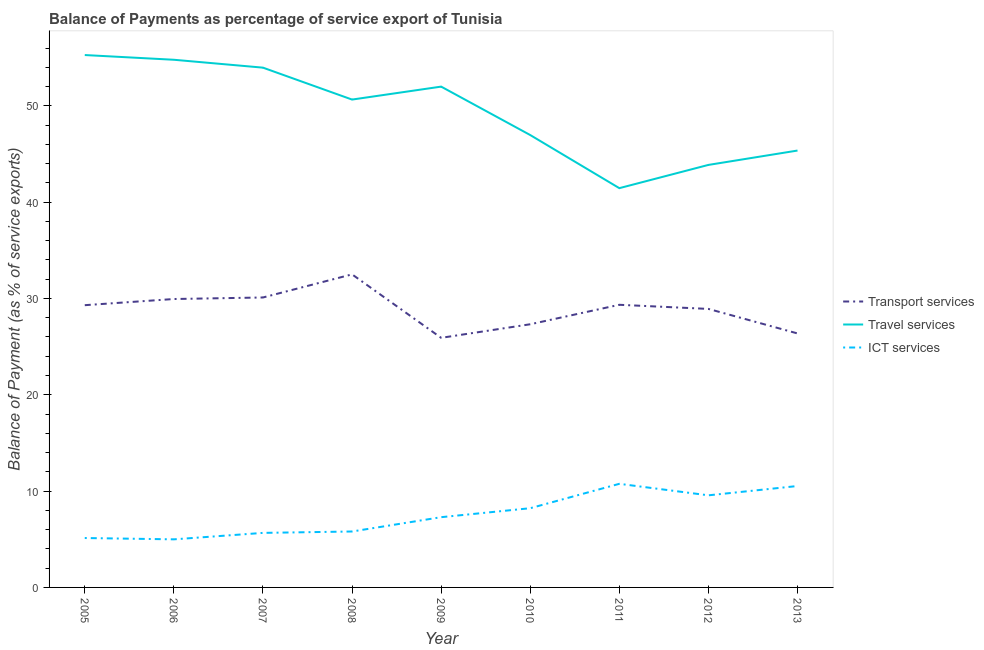How many different coloured lines are there?
Offer a very short reply. 3. Is the number of lines equal to the number of legend labels?
Make the answer very short. Yes. What is the balance of payment of travel services in 2008?
Your answer should be very brief. 50.65. Across all years, what is the maximum balance of payment of travel services?
Keep it short and to the point. 55.27. Across all years, what is the minimum balance of payment of travel services?
Your response must be concise. 41.45. In which year was the balance of payment of ict services maximum?
Your answer should be very brief. 2011. In which year was the balance of payment of travel services minimum?
Your response must be concise. 2011. What is the total balance of payment of ict services in the graph?
Offer a very short reply. 67.95. What is the difference between the balance of payment of transport services in 2011 and that in 2013?
Your answer should be compact. 2.97. What is the difference between the balance of payment of ict services in 2013 and the balance of payment of travel services in 2012?
Offer a very short reply. -33.33. What is the average balance of payment of travel services per year?
Keep it short and to the point. 49.36. In the year 2011, what is the difference between the balance of payment of ict services and balance of payment of transport services?
Offer a very short reply. -18.59. What is the ratio of the balance of payment of travel services in 2006 to that in 2009?
Keep it short and to the point. 1.05. Is the balance of payment of transport services in 2009 less than that in 2010?
Your response must be concise. Yes. Is the difference between the balance of payment of travel services in 2010 and 2011 greater than the difference between the balance of payment of transport services in 2010 and 2011?
Ensure brevity in your answer.  Yes. What is the difference between the highest and the second highest balance of payment of ict services?
Offer a very short reply. 0.23. What is the difference between the highest and the lowest balance of payment of travel services?
Provide a short and direct response. 13.82. Is the sum of the balance of payment of transport services in 2006 and 2007 greater than the maximum balance of payment of travel services across all years?
Offer a very short reply. Yes. Is it the case that in every year, the sum of the balance of payment of transport services and balance of payment of travel services is greater than the balance of payment of ict services?
Your answer should be very brief. Yes. Is the balance of payment of travel services strictly greater than the balance of payment of ict services over the years?
Your response must be concise. Yes. Is the balance of payment of transport services strictly less than the balance of payment of travel services over the years?
Provide a short and direct response. Yes. How many years are there in the graph?
Keep it short and to the point. 9. What is the difference between two consecutive major ticks on the Y-axis?
Your answer should be very brief. 10. Are the values on the major ticks of Y-axis written in scientific E-notation?
Offer a terse response. No. Does the graph contain any zero values?
Provide a short and direct response. No. Does the graph contain grids?
Offer a terse response. No. Where does the legend appear in the graph?
Keep it short and to the point. Center right. How many legend labels are there?
Keep it short and to the point. 3. How are the legend labels stacked?
Your answer should be compact. Vertical. What is the title of the graph?
Make the answer very short. Balance of Payments as percentage of service export of Tunisia. What is the label or title of the Y-axis?
Provide a succinct answer. Balance of Payment (as % of service exports). What is the Balance of Payment (as % of service exports) of Transport services in 2005?
Offer a terse response. 29.3. What is the Balance of Payment (as % of service exports) in Travel services in 2005?
Give a very brief answer. 55.27. What is the Balance of Payment (as % of service exports) in ICT services in 2005?
Make the answer very short. 5.13. What is the Balance of Payment (as % of service exports) in Transport services in 2006?
Your answer should be compact. 29.94. What is the Balance of Payment (as % of service exports) of Travel services in 2006?
Your answer should be compact. 54.78. What is the Balance of Payment (as % of service exports) in ICT services in 2006?
Provide a short and direct response. 4.99. What is the Balance of Payment (as % of service exports) in Transport services in 2007?
Keep it short and to the point. 30.1. What is the Balance of Payment (as % of service exports) of Travel services in 2007?
Provide a succinct answer. 53.96. What is the Balance of Payment (as % of service exports) in ICT services in 2007?
Your answer should be very brief. 5.66. What is the Balance of Payment (as % of service exports) in Transport services in 2008?
Make the answer very short. 32.5. What is the Balance of Payment (as % of service exports) of Travel services in 2008?
Make the answer very short. 50.65. What is the Balance of Payment (as % of service exports) of ICT services in 2008?
Your answer should be compact. 5.81. What is the Balance of Payment (as % of service exports) of Transport services in 2009?
Make the answer very short. 25.91. What is the Balance of Payment (as % of service exports) in Travel services in 2009?
Offer a terse response. 51.99. What is the Balance of Payment (as % of service exports) of ICT services in 2009?
Give a very brief answer. 7.29. What is the Balance of Payment (as % of service exports) of Transport services in 2010?
Your answer should be very brief. 27.32. What is the Balance of Payment (as % of service exports) of Travel services in 2010?
Provide a short and direct response. 46.96. What is the Balance of Payment (as % of service exports) in ICT services in 2010?
Offer a terse response. 8.22. What is the Balance of Payment (as % of service exports) in Transport services in 2011?
Make the answer very short. 29.34. What is the Balance of Payment (as % of service exports) of Travel services in 2011?
Your answer should be compact. 41.45. What is the Balance of Payment (as % of service exports) in ICT services in 2011?
Make the answer very short. 10.76. What is the Balance of Payment (as % of service exports) in Transport services in 2012?
Keep it short and to the point. 28.91. What is the Balance of Payment (as % of service exports) of Travel services in 2012?
Provide a succinct answer. 43.86. What is the Balance of Payment (as % of service exports) of ICT services in 2012?
Give a very brief answer. 9.56. What is the Balance of Payment (as % of service exports) in Transport services in 2013?
Give a very brief answer. 26.37. What is the Balance of Payment (as % of service exports) of Travel services in 2013?
Offer a terse response. 45.35. What is the Balance of Payment (as % of service exports) in ICT services in 2013?
Ensure brevity in your answer.  10.53. Across all years, what is the maximum Balance of Payment (as % of service exports) of Transport services?
Make the answer very short. 32.5. Across all years, what is the maximum Balance of Payment (as % of service exports) in Travel services?
Offer a terse response. 55.27. Across all years, what is the maximum Balance of Payment (as % of service exports) in ICT services?
Your answer should be very brief. 10.76. Across all years, what is the minimum Balance of Payment (as % of service exports) in Transport services?
Offer a terse response. 25.91. Across all years, what is the minimum Balance of Payment (as % of service exports) of Travel services?
Your response must be concise. 41.45. Across all years, what is the minimum Balance of Payment (as % of service exports) of ICT services?
Your response must be concise. 4.99. What is the total Balance of Payment (as % of service exports) of Transport services in the graph?
Your answer should be very brief. 259.7. What is the total Balance of Payment (as % of service exports) of Travel services in the graph?
Your answer should be very brief. 444.28. What is the total Balance of Payment (as % of service exports) in ICT services in the graph?
Offer a very short reply. 67.95. What is the difference between the Balance of Payment (as % of service exports) of Transport services in 2005 and that in 2006?
Provide a short and direct response. -0.64. What is the difference between the Balance of Payment (as % of service exports) in Travel services in 2005 and that in 2006?
Keep it short and to the point. 0.49. What is the difference between the Balance of Payment (as % of service exports) in ICT services in 2005 and that in 2006?
Your answer should be compact. 0.14. What is the difference between the Balance of Payment (as % of service exports) in Transport services in 2005 and that in 2007?
Your answer should be very brief. -0.8. What is the difference between the Balance of Payment (as % of service exports) in Travel services in 2005 and that in 2007?
Your response must be concise. 1.31. What is the difference between the Balance of Payment (as % of service exports) of ICT services in 2005 and that in 2007?
Ensure brevity in your answer.  -0.53. What is the difference between the Balance of Payment (as % of service exports) of Transport services in 2005 and that in 2008?
Ensure brevity in your answer.  -3.2. What is the difference between the Balance of Payment (as % of service exports) in Travel services in 2005 and that in 2008?
Your response must be concise. 4.62. What is the difference between the Balance of Payment (as % of service exports) in ICT services in 2005 and that in 2008?
Keep it short and to the point. -0.68. What is the difference between the Balance of Payment (as % of service exports) in Transport services in 2005 and that in 2009?
Your response must be concise. 3.39. What is the difference between the Balance of Payment (as % of service exports) of Travel services in 2005 and that in 2009?
Offer a terse response. 3.28. What is the difference between the Balance of Payment (as % of service exports) of ICT services in 2005 and that in 2009?
Provide a short and direct response. -2.16. What is the difference between the Balance of Payment (as % of service exports) of Transport services in 2005 and that in 2010?
Keep it short and to the point. 1.98. What is the difference between the Balance of Payment (as % of service exports) in Travel services in 2005 and that in 2010?
Your answer should be compact. 8.31. What is the difference between the Balance of Payment (as % of service exports) in ICT services in 2005 and that in 2010?
Provide a short and direct response. -3.1. What is the difference between the Balance of Payment (as % of service exports) of Transport services in 2005 and that in 2011?
Give a very brief answer. -0.04. What is the difference between the Balance of Payment (as % of service exports) in Travel services in 2005 and that in 2011?
Your answer should be compact. 13.82. What is the difference between the Balance of Payment (as % of service exports) of ICT services in 2005 and that in 2011?
Keep it short and to the point. -5.63. What is the difference between the Balance of Payment (as % of service exports) in Transport services in 2005 and that in 2012?
Keep it short and to the point. 0.39. What is the difference between the Balance of Payment (as % of service exports) in Travel services in 2005 and that in 2012?
Provide a short and direct response. 11.41. What is the difference between the Balance of Payment (as % of service exports) of ICT services in 2005 and that in 2012?
Make the answer very short. -4.43. What is the difference between the Balance of Payment (as % of service exports) in Transport services in 2005 and that in 2013?
Offer a terse response. 2.93. What is the difference between the Balance of Payment (as % of service exports) of Travel services in 2005 and that in 2013?
Give a very brief answer. 9.92. What is the difference between the Balance of Payment (as % of service exports) of ICT services in 2005 and that in 2013?
Your answer should be compact. -5.4. What is the difference between the Balance of Payment (as % of service exports) of Transport services in 2006 and that in 2007?
Give a very brief answer. -0.16. What is the difference between the Balance of Payment (as % of service exports) of Travel services in 2006 and that in 2007?
Your answer should be compact. 0.82. What is the difference between the Balance of Payment (as % of service exports) in ICT services in 2006 and that in 2007?
Provide a succinct answer. -0.67. What is the difference between the Balance of Payment (as % of service exports) in Transport services in 2006 and that in 2008?
Keep it short and to the point. -2.56. What is the difference between the Balance of Payment (as % of service exports) in Travel services in 2006 and that in 2008?
Give a very brief answer. 4.13. What is the difference between the Balance of Payment (as % of service exports) of ICT services in 2006 and that in 2008?
Your answer should be very brief. -0.82. What is the difference between the Balance of Payment (as % of service exports) of Transport services in 2006 and that in 2009?
Your response must be concise. 4.03. What is the difference between the Balance of Payment (as % of service exports) of Travel services in 2006 and that in 2009?
Keep it short and to the point. 2.79. What is the difference between the Balance of Payment (as % of service exports) in ICT services in 2006 and that in 2009?
Ensure brevity in your answer.  -2.3. What is the difference between the Balance of Payment (as % of service exports) in Transport services in 2006 and that in 2010?
Make the answer very short. 2.62. What is the difference between the Balance of Payment (as % of service exports) of Travel services in 2006 and that in 2010?
Provide a short and direct response. 7.82. What is the difference between the Balance of Payment (as % of service exports) in ICT services in 2006 and that in 2010?
Give a very brief answer. -3.23. What is the difference between the Balance of Payment (as % of service exports) in Transport services in 2006 and that in 2011?
Offer a very short reply. 0.6. What is the difference between the Balance of Payment (as % of service exports) in Travel services in 2006 and that in 2011?
Provide a short and direct response. 13.33. What is the difference between the Balance of Payment (as % of service exports) of ICT services in 2006 and that in 2011?
Offer a very short reply. -5.76. What is the difference between the Balance of Payment (as % of service exports) of Transport services in 2006 and that in 2012?
Provide a succinct answer. 1.03. What is the difference between the Balance of Payment (as % of service exports) in Travel services in 2006 and that in 2012?
Provide a succinct answer. 10.92. What is the difference between the Balance of Payment (as % of service exports) of ICT services in 2006 and that in 2012?
Offer a very short reply. -4.57. What is the difference between the Balance of Payment (as % of service exports) in Transport services in 2006 and that in 2013?
Your answer should be compact. 3.57. What is the difference between the Balance of Payment (as % of service exports) of Travel services in 2006 and that in 2013?
Provide a short and direct response. 9.43. What is the difference between the Balance of Payment (as % of service exports) of ICT services in 2006 and that in 2013?
Offer a terse response. -5.54. What is the difference between the Balance of Payment (as % of service exports) in Transport services in 2007 and that in 2008?
Give a very brief answer. -2.4. What is the difference between the Balance of Payment (as % of service exports) of Travel services in 2007 and that in 2008?
Make the answer very short. 3.31. What is the difference between the Balance of Payment (as % of service exports) of ICT services in 2007 and that in 2008?
Your answer should be very brief. -0.14. What is the difference between the Balance of Payment (as % of service exports) of Transport services in 2007 and that in 2009?
Your answer should be very brief. 4.19. What is the difference between the Balance of Payment (as % of service exports) in Travel services in 2007 and that in 2009?
Your answer should be compact. 1.97. What is the difference between the Balance of Payment (as % of service exports) in ICT services in 2007 and that in 2009?
Ensure brevity in your answer.  -1.63. What is the difference between the Balance of Payment (as % of service exports) in Transport services in 2007 and that in 2010?
Provide a short and direct response. 2.78. What is the difference between the Balance of Payment (as % of service exports) of Travel services in 2007 and that in 2010?
Your response must be concise. 7. What is the difference between the Balance of Payment (as % of service exports) of ICT services in 2007 and that in 2010?
Offer a terse response. -2.56. What is the difference between the Balance of Payment (as % of service exports) of Transport services in 2007 and that in 2011?
Keep it short and to the point. 0.76. What is the difference between the Balance of Payment (as % of service exports) in Travel services in 2007 and that in 2011?
Offer a very short reply. 12.51. What is the difference between the Balance of Payment (as % of service exports) of ICT services in 2007 and that in 2011?
Your response must be concise. -5.09. What is the difference between the Balance of Payment (as % of service exports) in Transport services in 2007 and that in 2012?
Provide a succinct answer. 1.19. What is the difference between the Balance of Payment (as % of service exports) of Travel services in 2007 and that in 2012?
Your response must be concise. 10.1. What is the difference between the Balance of Payment (as % of service exports) in ICT services in 2007 and that in 2012?
Give a very brief answer. -3.9. What is the difference between the Balance of Payment (as % of service exports) of Transport services in 2007 and that in 2013?
Your answer should be very brief. 3.73. What is the difference between the Balance of Payment (as % of service exports) of Travel services in 2007 and that in 2013?
Give a very brief answer. 8.61. What is the difference between the Balance of Payment (as % of service exports) of ICT services in 2007 and that in 2013?
Ensure brevity in your answer.  -4.87. What is the difference between the Balance of Payment (as % of service exports) in Transport services in 2008 and that in 2009?
Give a very brief answer. 6.59. What is the difference between the Balance of Payment (as % of service exports) in Travel services in 2008 and that in 2009?
Provide a short and direct response. -1.34. What is the difference between the Balance of Payment (as % of service exports) of ICT services in 2008 and that in 2009?
Provide a succinct answer. -1.49. What is the difference between the Balance of Payment (as % of service exports) in Transport services in 2008 and that in 2010?
Your response must be concise. 5.18. What is the difference between the Balance of Payment (as % of service exports) of Travel services in 2008 and that in 2010?
Ensure brevity in your answer.  3.68. What is the difference between the Balance of Payment (as % of service exports) of ICT services in 2008 and that in 2010?
Offer a terse response. -2.42. What is the difference between the Balance of Payment (as % of service exports) in Transport services in 2008 and that in 2011?
Ensure brevity in your answer.  3.16. What is the difference between the Balance of Payment (as % of service exports) in Travel services in 2008 and that in 2011?
Make the answer very short. 9.2. What is the difference between the Balance of Payment (as % of service exports) in ICT services in 2008 and that in 2011?
Your answer should be compact. -4.95. What is the difference between the Balance of Payment (as % of service exports) in Transport services in 2008 and that in 2012?
Provide a short and direct response. 3.59. What is the difference between the Balance of Payment (as % of service exports) of Travel services in 2008 and that in 2012?
Provide a succinct answer. 6.78. What is the difference between the Balance of Payment (as % of service exports) of ICT services in 2008 and that in 2012?
Keep it short and to the point. -3.76. What is the difference between the Balance of Payment (as % of service exports) in Transport services in 2008 and that in 2013?
Provide a short and direct response. 6.13. What is the difference between the Balance of Payment (as % of service exports) in Travel services in 2008 and that in 2013?
Your answer should be compact. 5.29. What is the difference between the Balance of Payment (as % of service exports) of ICT services in 2008 and that in 2013?
Give a very brief answer. -4.72. What is the difference between the Balance of Payment (as % of service exports) in Transport services in 2009 and that in 2010?
Give a very brief answer. -1.41. What is the difference between the Balance of Payment (as % of service exports) of Travel services in 2009 and that in 2010?
Ensure brevity in your answer.  5.03. What is the difference between the Balance of Payment (as % of service exports) of ICT services in 2009 and that in 2010?
Your answer should be compact. -0.93. What is the difference between the Balance of Payment (as % of service exports) in Transport services in 2009 and that in 2011?
Your answer should be very brief. -3.43. What is the difference between the Balance of Payment (as % of service exports) in Travel services in 2009 and that in 2011?
Provide a succinct answer. 10.54. What is the difference between the Balance of Payment (as % of service exports) in ICT services in 2009 and that in 2011?
Give a very brief answer. -3.46. What is the difference between the Balance of Payment (as % of service exports) in Transport services in 2009 and that in 2012?
Your answer should be very brief. -3. What is the difference between the Balance of Payment (as % of service exports) in Travel services in 2009 and that in 2012?
Give a very brief answer. 8.13. What is the difference between the Balance of Payment (as % of service exports) of ICT services in 2009 and that in 2012?
Offer a terse response. -2.27. What is the difference between the Balance of Payment (as % of service exports) in Transport services in 2009 and that in 2013?
Give a very brief answer. -0.46. What is the difference between the Balance of Payment (as % of service exports) of Travel services in 2009 and that in 2013?
Give a very brief answer. 6.64. What is the difference between the Balance of Payment (as % of service exports) in ICT services in 2009 and that in 2013?
Your answer should be compact. -3.24. What is the difference between the Balance of Payment (as % of service exports) of Transport services in 2010 and that in 2011?
Provide a short and direct response. -2.02. What is the difference between the Balance of Payment (as % of service exports) of Travel services in 2010 and that in 2011?
Ensure brevity in your answer.  5.51. What is the difference between the Balance of Payment (as % of service exports) in ICT services in 2010 and that in 2011?
Ensure brevity in your answer.  -2.53. What is the difference between the Balance of Payment (as % of service exports) in Transport services in 2010 and that in 2012?
Provide a short and direct response. -1.59. What is the difference between the Balance of Payment (as % of service exports) of Travel services in 2010 and that in 2012?
Keep it short and to the point. 3.1. What is the difference between the Balance of Payment (as % of service exports) in ICT services in 2010 and that in 2012?
Your answer should be compact. -1.34. What is the difference between the Balance of Payment (as % of service exports) of Transport services in 2010 and that in 2013?
Ensure brevity in your answer.  0.95. What is the difference between the Balance of Payment (as % of service exports) in Travel services in 2010 and that in 2013?
Your answer should be compact. 1.61. What is the difference between the Balance of Payment (as % of service exports) of ICT services in 2010 and that in 2013?
Keep it short and to the point. -2.3. What is the difference between the Balance of Payment (as % of service exports) of Transport services in 2011 and that in 2012?
Keep it short and to the point. 0.43. What is the difference between the Balance of Payment (as % of service exports) of Travel services in 2011 and that in 2012?
Ensure brevity in your answer.  -2.41. What is the difference between the Balance of Payment (as % of service exports) of ICT services in 2011 and that in 2012?
Provide a short and direct response. 1.19. What is the difference between the Balance of Payment (as % of service exports) in Transport services in 2011 and that in 2013?
Give a very brief answer. 2.97. What is the difference between the Balance of Payment (as % of service exports) in Travel services in 2011 and that in 2013?
Keep it short and to the point. -3.9. What is the difference between the Balance of Payment (as % of service exports) in ICT services in 2011 and that in 2013?
Provide a succinct answer. 0.23. What is the difference between the Balance of Payment (as % of service exports) in Transport services in 2012 and that in 2013?
Provide a short and direct response. 2.55. What is the difference between the Balance of Payment (as % of service exports) in Travel services in 2012 and that in 2013?
Make the answer very short. -1.49. What is the difference between the Balance of Payment (as % of service exports) in ICT services in 2012 and that in 2013?
Give a very brief answer. -0.97. What is the difference between the Balance of Payment (as % of service exports) in Transport services in 2005 and the Balance of Payment (as % of service exports) in Travel services in 2006?
Your response must be concise. -25.48. What is the difference between the Balance of Payment (as % of service exports) in Transport services in 2005 and the Balance of Payment (as % of service exports) in ICT services in 2006?
Your answer should be compact. 24.31. What is the difference between the Balance of Payment (as % of service exports) in Travel services in 2005 and the Balance of Payment (as % of service exports) in ICT services in 2006?
Keep it short and to the point. 50.28. What is the difference between the Balance of Payment (as % of service exports) of Transport services in 2005 and the Balance of Payment (as % of service exports) of Travel services in 2007?
Provide a short and direct response. -24.66. What is the difference between the Balance of Payment (as % of service exports) of Transport services in 2005 and the Balance of Payment (as % of service exports) of ICT services in 2007?
Your answer should be compact. 23.64. What is the difference between the Balance of Payment (as % of service exports) in Travel services in 2005 and the Balance of Payment (as % of service exports) in ICT services in 2007?
Offer a very short reply. 49.61. What is the difference between the Balance of Payment (as % of service exports) of Transport services in 2005 and the Balance of Payment (as % of service exports) of Travel services in 2008?
Keep it short and to the point. -21.35. What is the difference between the Balance of Payment (as % of service exports) in Transport services in 2005 and the Balance of Payment (as % of service exports) in ICT services in 2008?
Your response must be concise. 23.49. What is the difference between the Balance of Payment (as % of service exports) of Travel services in 2005 and the Balance of Payment (as % of service exports) of ICT services in 2008?
Provide a short and direct response. 49.46. What is the difference between the Balance of Payment (as % of service exports) in Transport services in 2005 and the Balance of Payment (as % of service exports) in Travel services in 2009?
Keep it short and to the point. -22.69. What is the difference between the Balance of Payment (as % of service exports) in Transport services in 2005 and the Balance of Payment (as % of service exports) in ICT services in 2009?
Provide a short and direct response. 22.01. What is the difference between the Balance of Payment (as % of service exports) in Travel services in 2005 and the Balance of Payment (as % of service exports) in ICT services in 2009?
Offer a terse response. 47.98. What is the difference between the Balance of Payment (as % of service exports) in Transport services in 2005 and the Balance of Payment (as % of service exports) in Travel services in 2010?
Your answer should be very brief. -17.66. What is the difference between the Balance of Payment (as % of service exports) in Transport services in 2005 and the Balance of Payment (as % of service exports) in ICT services in 2010?
Make the answer very short. 21.08. What is the difference between the Balance of Payment (as % of service exports) of Travel services in 2005 and the Balance of Payment (as % of service exports) of ICT services in 2010?
Make the answer very short. 47.05. What is the difference between the Balance of Payment (as % of service exports) of Transport services in 2005 and the Balance of Payment (as % of service exports) of Travel services in 2011?
Your answer should be compact. -12.15. What is the difference between the Balance of Payment (as % of service exports) in Transport services in 2005 and the Balance of Payment (as % of service exports) in ICT services in 2011?
Make the answer very short. 18.55. What is the difference between the Balance of Payment (as % of service exports) of Travel services in 2005 and the Balance of Payment (as % of service exports) of ICT services in 2011?
Your response must be concise. 44.51. What is the difference between the Balance of Payment (as % of service exports) of Transport services in 2005 and the Balance of Payment (as % of service exports) of Travel services in 2012?
Offer a terse response. -14.56. What is the difference between the Balance of Payment (as % of service exports) in Transport services in 2005 and the Balance of Payment (as % of service exports) in ICT services in 2012?
Provide a short and direct response. 19.74. What is the difference between the Balance of Payment (as % of service exports) in Travel services in 2005 and the Balance of Payment (as % of service exports) in ICT services in 2012?
Provide a short and direct response. 45.71. What is the difference between the Balance of Payment (as % of service exports) of Transport services in 2005 and the Balance of Payment (as % of service exports) of Travel services in 2013?
Provide a short and direct response. -16.05. What is the difference between the Balance of Payment (as % of service exports) in Transport services in 2005 and the Balance of Payment (as % of service exports) in ICT services in 2013?
Your answer should be compact. 18.77. What is the difference between the Balance of Payment (as % of service exports) in Travel services in 2005 and the Balance of Payment (as % of service exports) in ICT services in 2013?
Offer a terse response. 44.74. What is the difference between the Balance of Payment (as % of service exports) in Transport services in 2006 and the Balance of Payment (as % of service exports) in Travel services in 2007?
Provide a short and direct response. -24.02. What is the difference between the Balance of Payment (as % of service exports) in Transport services in 2006 and the Balance of Payment (as % of service exports) in ICT services in 2007?
Your answer should be very brief. 24.28. What is the difference between the Balance of Payment (as % of service exports) of Travel services in 2006 and the Balance of Payment (as % of service exports) of ICT services in 2007?
Provide a succinct answer. 49.12. What is the difference between the Balance of Payment (as % of service exports) in Transport services in 2006 and the Balance of Payment (as % of service exports) in Travel services in 2008?
Give a very brief answer. -20.71. What is the difference between the Balance of Payment (as % of service exports) in Transport services in 2006 and the Balance of Payment (as % of service exports) in ICT services in 2008?
Your response must be concise. 24.14. What is the difference between the Balance of Payment (as % of service exports) of Travel services in 2006 and the Balance of Payment (as % of service exports) of ICT services in 2008?
Your answer should be very brief. 48.97. What is the difference between the Balance of Payment (as % of service exports) of Transport services in 2006 and the Balance of Payment (as % of service exports) of Travel services in 2009?
Ensure brevity in your answer.  -22.05. What is the difference between the Balance of Payment (as % of service exports) in Transport services in 2006 and the Balance of Payment (as % of service exports) in ICT services in 2009?
Give a very brief answer. 22.65. What is the difference between the Balance of Payment (as % of service exports) in Travel services in 2006 and the Balance of Payment (as % of service exports) in ICT services in 2009?
Offer a very short reply. 47.49. What is the difference between the Balance of Payment (as % of service exports) in Transport services in 2006 and the Balance of Payment (as % of service exports) in Travel services in 2010?
Provide a short and direct response. -17.02. What is the difference between the Balance of Payment (as % of service exports) of Transport services in 2006 and the Balance of Payment (as % of service exports) of ICT services in 2010?
Ensure brevity in your answer.  21.72. What is the difference between the Balance of Payment (as % of service exports) in Travel services in 2006 and the Balance of Payment (as % of service exports) in ICT services in 2010?
Keep it short and to the point. 46.55. What is the difference between the Balance of Payment (as % of service exports) in Transport services in 2006 and the Balance of Payment (as % of service exports) in Travel services in 2011?
Your answer should be very brief. -11.51. What is the difference between the Balance of Payment (as % of service exports) in Transport services in 2006 and the Balance of Payment (as % of service exports) in ICT services in 2011?
Offer a very short reply. 19.19. What is the difference between the Balance of Payment (as % of service exports) in Travel services in 2006 and the Balance of Payment (as % of service exports) in ICT services in 2011?
Provide a short and direct response. 44.02. What is the difference between the Balance of Payment (as % of service exports) in Transport services in 2006 and the Balance of Payment (as % of service exports) in Travel services in 2012?
Offer a very short reply. -13.92. What is the difference between the Balance of Payment (as % of service exports) in Transport services in 2006 and the Balance of Payment (as % of service exports) in ICT services in 2012?
Offer a terse response. 20.38. What is the difference between the Balance of Payment (as % of service exports) of Travel services in 2006 and the Balance of Payment (as % of service exports) of ICT services in 2012?
Ensure brevity in your answer.  45.22. What is the difference between the Balance of Payment (as % of service exports) of Transport services in 2006 and the Balance of Payment (as % of service exports) of Travel services in 2013?
Offer a terse response. -15.41. What is the difference between the Balance of Payment (as % of service exports) in Transport services in 2006 and the Balance of Payment (as % of service exports) in ICT services in 2013?
Provide a short and direct response. 19.41. What is the difference between the Balance of Payment (as % of service exports) of Travel services in 2006 and the Balance of Payment (as % of service exports) of ICT services in 2013?
Your answer should be very brief. 44.25. What is the difference between the Balance of Payment (as % of service exports) of Transport services in 2007 and the Balance of Payment (as % of service exports) of Travel services in 2008?
Offer a terse response. -20.55. What is the difference between the Balance of Payment (as % of service exports) of Transport services in 2007 and the Balance of Payment (as % of service exports) of ICT services in 2008?
Your answer should be compact. 24.29. What is the difference between the Balance of Payment (as % of service exports) of Travel services in 2007 and the Balance of Payment (as % of service exports) of ICT services in 2008?
Your response must be concise. 48.15. What is the difference between the Balance of Payment (as % of service exports) in Transport services in 2007 and the Balance of Payment (as % of service exports) in Travel services in 2009?
Your response must be concise. -21.89. What is the difference between the Balance of Payment (as % of service exports) in Transport services in 2007 and the Balance of Payment (as % of service exports) in ICT services in 2009?
Make the answer very short. 22.81. What is the difference between the Balance of Payment (as % of service exports) of Travel services in 2007 and the Balance of Payment (as % of service exports) of ICT services in 2009?
Your response must be concise. 46.67. What is the difference between the Balance of Payment (as % of service exports) of Transport services in 2007 and the Balance of Payment (as % of service exports) of Travel services in 2010?
Make the answer very short. -16.86. What is the difference between the Balance of Payment (as % of service exports) in Transport services in 2007 and the Balance of Payment (as % of service exports) in ICT services in 2010?
Make the answer very short. 21.88. What is the difference between the Balance of Payment (as % of service exports) of Travel services in 2007 and the Balance of Payment (as % of service exports) of ICT services in 2010?
Your answer should be compact. 45.74. What is the difference between the Balance of Payment (as % of service exports) of Transport services in 2007 and the Balance of Payment (as % of service exports) of Travel services in 2011?
Your answer should be compact. -11.35. What is the difference between the Balance of Payment (as % of service exports) in Transport services in 2007 and the Balance of Payment (as % of service exports) in ICT services in 2011?
Make the answer very short. 19.34. What is the difference between the Balance of Payment (as % of service exports) in Travel services in 2007 and the Balance of Payment (as % of service exports) in ICT services in 2011?
Provide a succinct answer. 43.21. What is the difference between the Balance of Payment (as % of service exports) of Transport services in 2007 and the Balance of Payment (as % of service exports) of Travel services in 2012?
Provide a succinct answer. -13.76. What is the difference between the Balance of Payment (as % of service exports) of Transport services in 2007 and the Balance of Payment (as % of service exports) of ICT services in 2012?
Your response must be concise. 20.54. What is the difference between the Balance of Payment (as % of service exports) of Travel services in 2007 and the Balance of Payment (as % of service exports) of ICT services in 2012?
Provide a short and direct response. 44.4. What is the difference between the Balance of Payment (as % of service exports) of Transport services in 2007 and the Balance of Payment (as % of service exports) of Travel services in 2013?
Your answer should be compact. -15.25. What is the difference between the Balance of Payment (as % of service exports) of Transport services in 2007 and the Balance of Payment (as % of service exports) of ICT services in 2013?
Keep it short and to the point. 19.57. What is the difference between the Balance of Payment (as % of service exports) in Travel services in 2007 and the Balance of Payment (as % of service exports) in ICT services in 2013?
Offer a very short reply. 43.43. What is the difference between the Balance of Payment (as % of service exports) in Transport services in 2008 and the Balance of Payment (as % of service exports) in Travel services in 2009?
Make the answer very short. -19.49. What is the difference between the Balance of Payment (as % of service exports) in Transport services in 2008 and the Balance of Payment (as % of service exports) in ICT services in 2009?
Offer a terse response. 25.21. What is the difference between the Balance of Payment (as % of service exports) of Travel services in 2008 and the Balance of Payment (as % of service exports) of ICT services in 2009?
Ensure brevity in your answer.  43.35. What is the difference between the Balance of Payment (as % of service exports) of Transport services in 2008 and the Balance of Payment (as % of service exports) of Travel services in 2010?
Keep it short and to the point. -14.46. What is the difference between the Balance of Payment (as % of service exports) of Transport services in 2008 and the Balance of Payment (as % of service exports) of ICT services in 2010?
Your answer should be compact. 24.28. What is the difference between the Balance of Payment (as % of service exports) in Travel services in 2008 and the Balance of Payment (as % of service exports) in ICT services in 2010?
Ensure brevity in your answer.  42.42. What is the difference between the Balance of Payment (as % of service exports) of Transport services in 2008 and the Balance of Payment (as % of service exports) of Travel services in 2011?
Offer a terse response. -8.95. What is the difference between the Balance of Payment (as % of service exports) in Transport services in 2008 and the Balance of Payment (as % of service exports) in ICT services in 2011?
Provide a short and direct response. 21.74. What is the difference between the Balance of Payment (as % of service exports) in Travel services in 2008 and the Balance of Payment (as % of service exports) in ICT services in 2011?
Provide a short and direct response. 39.89. What is the difference between the Balance of Payment (as % of service exports) in Transport services in 2008 and the Balance of Payment (as % of service exports) in Travel services in 2012?
Make the answer very short. -11.36. What is the difference between the Balance of Payment (as % of service exports) of Transport services in 2008 and the Balance of Payment (as % of service exports) of ICT services in 2012?
Your answer should be very brief. 22.94. What is the difference between the Balance of Payment (as % of service exports) of Travel services in 2008 and the Balance of Payment (as % of service exports) of ICT services in 2012?
Offer a terse response. 41.09. What is the difference between the Balance of Payment (as % of service exports) of Transport services in 2008 and the Balance of Payment (as % of service exports) of Travel services in 2013?
Keep it short and to the point. -12.85. What is the difference between the Balance of Payment (as % of service exports) in Transport services in 2008 and the Balance of Payment (as % of service exports) in ICT services in 2013?
Provide a succinct answer. 21.97. What is the difference between the Balance of Payment (as % of service exports) in Travel services in 2008 and the Balance of Payment (as % of service exports) in ICT services in 2013?
Keep it short and to the point. 40.12. What is the difference between the Balance of Payment (as % of service exports) in Transport services in 2009 and the Balance of Payment (as % of service exports) in Travel services in 2010?
Your response must be concise. -21.05. What is the difference between the Balance of Payment (as % of service exports) in Transport services in 2009 and the Balance of Payment (as % of service exports) in ICT services in 2010?
Your response must be concise. 17.69. What is the difference between the Balance of Payment (as % of service exports) of Travel services in 2009 and the Balance of Payment (as % of service exports) of ICT services in 2010?
Your answer should be very brief. 43.77. What is the difference between the Balance of Payment (as % of service exports) of Transport services in 2009 and the Balance of Payment (as % of service exports) of Travel services in 2011?
Your answer should be very brief. -15.54. What is the difference between the Balance of Payment (as % of service exports) of Transport services in 2009 and the Balance of Payment (as % of service exports) of ICT services in 2011?
Give a very brief answer. 15.16. What is the difference between the Balance of Payment (as % of service exports) of Travel services in 2009 and the Balance of Payment (as % of service exports) of ICT services in 2011?
Give a very brief answer. 41.24. What is the difference between the Balance of Payment (as % of service exports) in Transport services in 2009 and the Balance of Payment (as % of service exports) in Travel services in 2012?
Provide a short and direct response. -17.95. What is the difference between the Balance of Payment (as % of service exports) in Transport services in 2009 and the Balance of Payment (as % of service exports) in ICT services in 2012?
Give a very brief answer. 16.35. What is the difference between the Balance of Payment (as % of service exports) of Travel services in 2009 and the Balance of Payment (as % of service exports) of ICT services in 2012?
Provide a short and direct response. 42.43. What is the difference between the Balance of Payment (as % of service exports) in Transport services in 2009 and the Balance of Payment (as % of service exports) in Travel services in 2013?
Ensure brevity in your answer.  -19.44. What is the difference between the Balance of Payment (as % of service exports) in Transport services in 2009 and the Balance of Payment (as % of service exports) in ICT services in 2013?
Provide a succinct answer. 15.38. What is the difference between the Balance of Payment (as % of service exports) in Travel services in 2009 and the Balance of Payment (as % of service exports) in ICT services in 2013?
Offer a terse response. 41.46. What is the difference between the Balance of Payment (as % of service exports) of Transport services in 2010 and the Balance of Payment (as % of service exports) of Travel services in 2011?
Provide a short and direct response. -14.13. What is the difference between the Balance of Payment (as % of service exports) in Transport services in 2010 and the Balance of Payment (as % of service exports) in ICT services in 2011?
Provide a succinct answer. 16.56. What is the difference between the Balance of Payment (as % of service exports) of Travel services in 2010 and the Balance of Payment (as % of service exports) of ICT services in 2011?
Your answer should be compact. 36.21. What is the difference between the Balance of Payment (as % of service exports) in Transport services in 2010 and the Balance of Payment (as % of service exports) in Travel services in 2012?
Your response must be concise. -16.54. What is the difference between the Balance of Payment (as % of service exports) of Transport services in 2010 and the Balance of Payment (as % of service exports) of ICT services in 2012?
Offer a very short reply. 17.76. What is the difference between the Balance of Payment (as % of service exports) in Travel services in 2010 and the Balance of Payment (as % of service exports) in ICT services in 2012?
Give a very brief answer. 37.4. What is the difference between the Balance of Payment (as % of service exports) in Transport services in 2010 and the Balance of Payment (as % of service exports) in Travel services in 2013?
Ensure brevity in your answer.  -18.03. What is the difference between the Balance of Payment (as % of service exports) in Transport services in 2010 and the Balance of Payment (as % of service exports) in ICT services in 2013?
Make the answer very short. 16.79. What is the difference between the Balance of Payment (as % of service exports) in Travel services in 2010 and the Balance of Payment (as % of service exports) in ICT services in 2013?
Give a very brief answer. 36.44. What is the difference between the Balance of Payment (as % of service exports) of Transport services in 2011 and the Balance of Payment (as % of service exports) of Travel services in 2012?
Your response must be concise. -14.52. What is the difference between the Balance of Payment (as % of service exports) of Transport services in 2011 and the Balance of Payment (as % of service exports) of ICT services in 2012?
Your answer should be very brief. 19.78. What is the difference between the Balance of Payment (as % of service exports) in Travel services in 2011 and the Balance of Payment (as % of service exports) in ICT services in 2012?
Keep it short and to the point. 31.89. What is the difference between the Balance of Payment (as % of service exports) in Transport services in 2011 and the Balance of Payment (as % of service exports) in Travel services in 2013?
Offer a very short reply. -16.01. What is the difference between the Balance of Payment (as % of service exports) of Transport services in 2011 and the Balance of Payment (as % of service exports) of ICT services in 2013?
Offer a terse response. 18.81. What is the difference between the Balance of Payment (as % of service exports) of Travel services in 2011 and the Balance of Payment (as % of service exports) of ICT services in 2013?
Give a very brief answer. 30.92. What is the difference between the Balance of Payment (as % of service exports) of Transport services in 2012 and the Balance of Payment (as % of service exports) of Travel services in 2013?
Provide a succinct answer. -16.44. What is the difference between the Balance of Payment (as % of service exports) of Transport services in 2012 and the Balance of Payment (as % of service exports) of ICT services in 2013?
Provide a succinct answer. 18.38. What is the difference between the Balance of Payment (as % of service exports) of Travel services in 2012 and the Balance of Payment (as % of service exports) of ICT services in 2013?
Your answer should be very brief. 33.33. What is the average Balance of Payment (as % of service exports) in Transport services per year?
Give a very brief answer. 28.86. What is the average Balance of Payment (as % of service exports) of Travel services per year?
Provide a short and direct response. 49.36. What is the average Balance of Payment (as % of service exports) of ICT services per year?
Offer a terse response. 7.55. In the year 2005, what is the difference between the Balance of Payment (as % of service exports) in Transport services and Balance of Payment (as % of service exports) in Travel services?
Make the answer very short. -25.97. In the year 2005, what is the difference between the Balance of Payment (as % of service exports) of Transport services and Balance of Payment (as % of service exports) of ICT services?
Your answer should be very brief. 24.17. In the year 2005, what is the difference between the Balance of Payment (as % of service exports) of Travel services and Balance of Payment (as % of service exports) of ICT services?
Keep it short and to the point. 50.14. In the year 2006, what is the difference between the Balance of Payment (as % of service exports) of Transport services and Balance of Payment (as % of service exports) of Travel services?
Ensure brevity in your answer.  -24.84. In the year 2006, what is the difference between the Balance of Payment (as % of service exports) in Transport services and Balance of Payment (as % of service exports) in ICT services?
Offer a very short reply. 24.95. In the year 2006, what is the difference between the Balance of Payment (as % of service exports) in Travel services and Balance of Payment (as % of service exports) in ICT services?
Ensure brevity in your answer.  49.79. In the year 2007, what is the difference between the Balance of Payment (as % of service exports) of Transport services and Balance of Payment (as % of service exports) of Travel services?
Your answer should be compact. -23.86. In the year 2007, what is the difference between the Balance of Payment (as % of service exports) in Transport services and Balance of Payment (as % of service exports) in ICT services?
Offer a terse response. 24.44. In the year 2007, what is the difference between the Balance of Payment (as % of service exports) of Travel services and Balance of Payment (as % of service exports) of ICT services?
Offer a very short reply. 48.3. In the year 2008, what is the difference between the Balance of Payment (as % of service exports) of Transport services and Balance of Payment (as % of service exports) of Travel services?
Your answer should be compact. -18.15. In the year 2008, what is the difference between the Balance of Payment (as % of service exports) of Transport services and Balance of Payment (as % of service exports) of ICT services?
Offer a very short reply. 26.69. In the year 2008, what is the difference between the Balance of Payment (as % of service exports) in Travel services and Balance of Payment (as % of service exports) in ICT services?
Provide a short and direct response. 44.84. In the year 2009, what is the difference between the Balance of Payment (as % of service exports) of Transport services and Balance of Payment (as % of service exports) of Travel services?
Ensure brevity in your answer.  -26.08. In the year 2009, what is the difference between the Balance of Payment (as % of service exports) in Transport services and Balance of Payment (as % of service exports) in ICT services?
Give a very brief answer. 18.62. In the year 2009, what is the difference between the Balance of Payment (as % of service exports) of Travel services and Balance of Payment (as % of service exports) of ICT services?
Ensure brevity in your answer.  44.7. In the year 2010, what is the difference between the Balance of Payment (as % of service exports) in Transport services and Balance of Payment (as % of service exports) in Travel services?
Give a very brief answer. -19.64. In the year 2010, what is the difference between the Balance of Payment (as % of service exports) of Transport services and Balance of Payment (as % of service exports) of ICT services?
Provide a succinct answer. 19.1. In the year 2010, what is the difference between the Balance of Payment (as % of service exports) in Travel services and Balance of Payment (as % of service exports) in ICT services?
Your answer should be very brief. 38.74. In the year 2011, what is the difference between the Balance of Payment (as % of service exports) in Transport services and Balance of Payment (as % of service exports) in Travel services?
Offer a very short reply. -12.11. In the year 2011, what is the difference between the Balance of Payment (as % of service exports) of Transport services and Balance of Payment (as % of service exports) of ICT services?
Provide a short and direct response. 18.59. In the year 2011, what is the difference between the Balance of Payment (as % of service exports) of Travel services and Balance of Payment (as % of service exports) of ICT services?
Offer a very short reply. 30.69. In the year 2012, what is the difference between the Balance of Payment (as % of service exports) in Transport services and Balance of Payment (as % of service exports) in Travel services?
Give a very brief answer. -14.95. In the year 2012, what is the difference between the Balance of Payment (as % of service exports) of Transport services and Balance of Payment (as % of service exports) of ICT services?
Ensure brevity in your answer.  19.35. In the year 2012, what is the difference between the Balance of Payment (as % of service exports) in Travel services and Balance of Payment (as % of service exports) in ICT services?
Provide a short and direct response. 34.3. In the year 2013, what is the difference between the Balance of Payment (as % of service exports) in Transport services and Balance of Payment (as % of service exports) in Travel services?
Provide a short and direct response. -18.99. In the year 2013, what is the difference between the Balance of Payment (as % of service exports) in Transport services and Balance of Payment (as % of service exports) in ICT services?
Your answer should be compact. 15.84. In the year 2013, what is the difference between the Balance of Payment (as % of service exports) in Travel services and Balance of Payment (as % of service exports) in ICT services?
Provide a short and direct response. 34.83. What is the ratio of the Balance of Payment (as % of service exports) in Transport services in 2005 to that in 2006?
Provide a succinct answer. 0.98. What is the ratio of the Balance of Payment (as % of service exports) in Travel services in 2005 to that in 2006?
Your response must be concise. 1.01. What is the ratio of the Balance of Payment (as % of service exports) of ICT services in 2005 to that in 2006?
Provide a succinct answer. 1.03. What is the ratio of the Balance of Payment (as % of service exports) of Transport services in 2005 to that in 2007?
Offer a very short reply. 0.97. What is the ratio of the Balance of Payment (as % of service exports) in Travel services in 2005 to that in 2007?
Keep it short and to the point. 1.02. What is the ratio of the Balance of Payment (as % of service exports) of ICT services in 2005 to that in 2007?
Give a very brief answer. 0.91. What is the ratio of the Balance of Payment (as % of service exports) in Transport services in 2005 to that in 2008?
Provide a short and direct response. 0.9. What is the ratio of the Balance of Payment (as % of service exports) of Travel services in 2005 to that in 2008?
Ensure brevity in your answer.  1.09. What is the ratio of the Balance of Payment (as % of service exports) of ICT services in 2005 to that in 2008?
Ensure brevity in your answer.  0.88. What is the ratio of the Balance of Payment (as % of service exports) in Transport services in 2005 to that in 2009?
Provide a short and direct response. 1.13. What is the ratio of the Balance of Payment (as % of service exports) in Travel services in 2005 to that in 2009?
Your answer should be very brief. 1.06. What is the ratio of the Balance of Payment (as % of service exports) in ICT services in 2005 to that in 2009?
Keep it short and to the point. 0.7. What is the ratio of the Balance of Payment (as % of service exports) in Transport services in 2005 to that in 2010?
Provide a succinct answer. 1.07. What is the ratio of the Balance of Payment (as % of service exports) in Travel services in 2005 to that in 2010?
Your answer should be compact. 1.18. What is the ratio of the Balance of Payment (as % of service exports) of ICT services in 2005 to that in 2010?
Offer a terse response. 0.62. What is the ratio of the Balance of Payment (as % of service exports) in Transport services in 2005 to that in 2011?
Offer a terse response. 1. What is the ratio of the Balance of Payment (as % of service exports) of Travel services in 2005 to that in 2011?
Provide a succinct answer. 1.33. What is the ratio of the Balance of Payment (as % of service exports) of ICT services in 2005 to that in 2011?
Make the answer very short. 0.48. What is the ratio of the Balance of Payment (as % of service exports) of Transport services in 2005 to that in 2012?
Your response must be concise. 1.01. What is the ratio of the Balance of Payment (as % of service exports) of Travel services in 2005 to that in 2012?
Ensure brevity in your answer.  1.26. What is the ratio of the Balance of Payment (as % of service exports) in ICT services in 2005 to that in 2012?
Give a very brief answer. 0.54. What is the ratio of the Balance of Payment (as % of service exports) in Transport services in 2005 to that in 2013?
Your answer should be very brief. 1.11. What is the ratio of the Balance of Payment (as % of service exports) in Travel services in 2005 to that in 2013?
Your answer should be compact. 1.22. What is the ratio of the Balance of Payment (as % of service exports) in ICT services in 2005 to that in 2013?
Your response must be concise. 0.49. What is the ratio of the Balance of Payment (as % of service exports) in Travel services in 2006 to that in 2007?
Your answer should be very brief. 1.02. What is the ratio of the Balance of Payment (as % of service exports) in ICT services in 2006 to that in 2007?
Provide a succinct answer. 0.88. What is the ratio of the Balance of Payment (as % of service exports) in Transport services in 2006 to that in 2008?
Your response must be concise. 0.92. What is the ratio of the Balance of Payment (as % of service exports) of Travel services in 2006 to that in 2008?
Ensure brevity in your answer.  1.08. What is the ratio of the Balance of Payment (as % of service exports) in ICT services in 2006 to that in 2008?
Ensure brevity in your answer.  0.86. What is the ratio of the Balance of Payment (as % of service exports) of Transport services in 2006 to that in 2009?
Your answer should be very brief. 1.16. What is the ratio of the Balance of Payment (as % of service exports) of Travel services in 2006 to that in 2009?
Your answer should be very brief. 1.05. What is the ratio of the Balance of Payment (as % of service exports) of ICT services in 2006 to that in 2009?
Offer a very short reply. 0.68. What is the ratio of the Balance of Payment (as % of service exports) in Transport services in 2006 to that in 2010?
Make the answer very short. 1.1. What is the ratio of the Balance of Payment (as % of service exports) in Travel services in 2006 to that in 2010?
Offer a very short reply. 1.17. What is the ratio of the Balance of Payment (as % of service exports) in ICT services in 2006 to that in 2010?
Provide a short and direct response. 0.61. What is the ratio of the Balance of Payment (as % of service exports) in Transport services in 2006 to that in 2011?
Give a very brief answer. 1.02. What is the ratio of the Balance of Payment (as % of service exports) of Travel services in 2006 to that in 2011?
Your answer should be very brief. 1.32. What is the ratio of the Balance of Payment (as % of service exports) of ICT services in 2006 to that in 2011?
Give a very brief answer. 0.46. What is the ratio of the Balance of Payment (as % of service exports) in Transport services in 2006 to that in 2012?
Provide a succinct answer. 1.04. What is the ratio of the Balance of Payment (as % of service exports) in Travel services in 2006 to that in 2012?
Keep it short and to the point. 1.25. What is the ratio of the Balance of Payment (as % of service exports) of ICT services in 2006 to that in 2012?
Make the answer very short. 0.52. What is the ratio of the Balance of Payment (as % of service exports) of Transport services in 2006 to that in 2013?
Offer a terse response. 1.14. What is the ratio of the Balance of Payment (as % of service exports) of Travel services in 2006 to that in 2013?
Your answer should be very brief. 1.21. What is the ratio of the Balance of Payment (as % of service exports) of ICT services in 2006 to that in 2013?
Provide a short and direct response. 0.47. What is the ratio of the Balance of Payment (as % of service exports) in Transport services in 2007 to that in 2008?
Your answer should be compact. 0.93. What is the ratio of the Balance of Payment (as % of service exports) in Travel services in 2007 to that in 2008?
Your answer should be very brief. 1.07. What is the ratio of the Balance of Payment (as % of service exports) of ICT services in 2007 to that in 2008?
Your response must be concise. 0.98. What is the ratio of the Balance of Payment (as % of service exports) of Transport services in 2007 to that in 2009?
Provide a succinct answer. 1.16. What is the ratio of the Balance of Payment (as % of service exports) of Travel services in 2007 to that in 2009?
Your answer should be compact. 1.04. What is the ratio of the Balance of Payment (as % of service exports) of ICT services in 2007 to that in 2009?
Your response must be concise. 0.78. What is the ratio of the Balance of Payment (as % of service exports) in Transport services in 2007 to that in 2010?
Your response must be concise. 1.1. What is the ratio of the Balance of Payment (as % of service exports) in Travel services in 2007 to that in 2010?
Your answer should be compact. 1.15. What is the ratio of the Balance of Payment (as % of service exports) in ICT services in 2007 to that in 2010?
Your answer should be very brief. 0.69. What is the ratio of the Balance of Payment (as % of service exports) of Transport services in 2007 to that in 2011?
Ensure brevity in your answer.  1.03. What is the ratio of the Balance of Payment (as % of service exports) in Travel services in 2007 to that in 2011?
Keep it short and to the point. 1.3. What is the ratio of the Balance of Payment (as % of service exports) in ICT services in 2007 to that in 2011?
Provide a succinct answer. 0.53. What is the ratio of the Balance of Payment (as % of service exports) in Transport services in 2007 to that in 2012?
Your response must be concise. 1.04. What is the ratio of the Balance of Payment (as % of service exports) in Travel services in 2007 to that in 2012?
Offer a very short reply. 1.23. What is the ratio of the Balance of Payment (as % of service exports) of ICT services in 2007 to that in 2012?
Ensure brevity in your answer.  0.59. What is the ratio of the Balance of Payment (as % of service exports) of Transport services in 2007 to that in 2013?
Your answer should be compact. 1.14. What is the ratio of the Balance of Payment (as % of service exports) of Travel services in 2007 to that in 2013?
Your answer should be compact. 1.19. What is the ratio of the Balance of Payment (as % of service exports) in ICT services in 2007 to that in 2013?
Give a very brief answer. 0.54. What is the ratio of the Balance of Payment (as % of service exports) in Transport services in 2008 to that in 2009?
Provide a short and direct response. 1.25. What is the ratio of the Balance of Payment (as % of service exports) of Travel services in 2008 to that in 2009?
Make the answer very short. 0.97. What is the ratio of the Balance of Payment (as % of service exports) of ICT services in 2008 to that in 2009?
Make the answer very short. 0.8. What is the ratio of the Balance of Payment (as % of service exports) in Transport services in 2008 to that in 2010?
Your answer should be very brief. 1.19. What is the ratio of the Balance of Payment (as % of service exports) in Travel services in 2008 to that in 2010?
Offer a terse response. 1.08. What is the ratio of the Balance of Payment (as % of service exports) in ICT services in 2008 to that in 2010?
Keep it short and to the point. 0.71. What is the ratio of the Balance of Payment (as % of service exports) of Transport services in 2008 to that in 2011?
Offer a very short reply. 1.11. What is the ratio of the Balance of Payment (as % of service exports) of Travel services in 2008 to that in 2011?
Your answer should be compact. 1.22. What is the ratio of the Balance of Payment (as % of service exports) in ICT services in 2008 to that in 2011?
Offer a terse response. 0.54. What is the ratio of the Balance of Payment (as % of service exports) of Transport services in 2008 to that in 2012?
Your answer should be very brief. 1.12. What is the ratio of the Balance of Payment (as % of service exports) of Travel services in 2008 to that in 2012?
Ensure brevity in your answer.  1.15. What is the ratio of the Balance of Payment (as % of service exports) of ICT services in 2008 to that in 2012?
Make the answer very short. 0.61. What is the ratio of the Balance of Payment (as % of service exports) of Transport services in 2008 to that in 2013?
Your answer should be very brief. 1.23. What is the ratio of the Balance of Payment (as % of service exports) of Travel services in 2008 to that in 2013?
Your response must be concise. 1.12. What is the ratio of the Balance of Payment (as % of service exports) in ICT services in 2008 to that in 2013?
Offer a terse response. 0.55. What is the ratio of the Balance of Payment (as % of service exports) in Transport services in 2009 to that in 2010?
Provide a short and direct response. 0.95. What is the ratio of the Balance of Payment (as % of service exports) of Travel services in 2009 to that in 2010?
Keep it short and to the point. 1.11. What is the ratio of the Balance of Payment (as % of service exports) of ICT services in 2009 to that in 2010?
Provide a succinct answer. 0.89. What is the ratio of the Balance of Payment (as % of service exports) of Transport services in 2009 to that in 2011?
Make the answer very short. 0.88. What is the ratio of the Balance of Payment (as % of service exports) in Travel services in 2009 to that in 2011?
Make the answer very short. 1.25. What is the ratio of the Balance of Payment (as % of service exports) of ICT services in 2009 to that in 2011?
Give a very brief answer. 0.68. What is the ratio of the Balance of Payment (as % of service exports) in Transport services in 2009 to that in 2012?
Your answer should be very brief. 0.9. What is the ratio of the Balance of Payment (as % of service exports) of Travel services in 2009 to that in 2012?
Offer a very short reply. 1.19. What is the ratio of the Balance of Payment (as % of service exports) of ICT services in 2009 to that in 2012?
Your answer should be compact. 0.76. What is the ratio of the Balance of Payment (as % of service exports) in Transport services in 2009 to that in 2013?
Provide a short and direct response. 0.98. What is the ratio of the Balance of Payment (as % of service exports) of Travel services in 2009 to that in 2013?
Offer a very short reply. 1.15. What is the ratio of the Balance of Payment (as % of service exports) of ICT services in 2009 to that in 2013?
Offer a terse response. 0.69. What is the ratio of the Balance of Payment (as % of service exports) in Transport services in 2010 to that in 2011?
Your answer should be compact. 0.93. What is the ratio of the Balance of Payment (as % of service exports) in Travel services in 2010 to that in 2011?
Provide a short and direct response. 1.13. What is the ratio of the Balance of Payment (as % of service exports) in ICT services in 2010 to that in 2011?
Give a very brief answer. 0.76. What is the ratio of the Balance of Payment (as % of service exports) of Transport services in 2010 to that in 2012?
Offer a terse response. 0.94. What is the ratio of the Balance of Payment (as % of service exports) of Travel services in 2010 to that in 2012?
Your answer should be compact. 1.07. What is the ratio of the Balance of Payment (as % of service exports) in ICT services in 2010 to that in 2012?
Provide a succinct answer. 0.86. What is the ratio of the Balance of Payment (as % of service exports) of Transport services in 2010 to that in 2013?
Offer a terse response. 1.04. What is the ratio of the Balance of Payment (as % of service exports) in Travel services in 2010 to that in 2013?
Your answer should be compact. 1.04. What is the ratio of the Balance of Payment (as % of service exports) of ICT services in 2010 to that in 2013?
Ensure brevity in your answer.  0.78. What is the ratio of the Balance of Payment (as % of service exports) of Transport services in 2011 to that in 2012?
Your answer should be compact. 1.01. What is the ratio of the Balance of Payment (as % of service exports) of Travel services in 2011 to that in 2012?
Give a very brief answer. 0.94. What is the ratio of the Balance of Payment (as % of service exports) of ICT services in 2011 to that in 2012?
Provide a short and direct response. 1.12. What is the ratio of the Balance of Payment (as % of service exports) of Transport services in 2011 to that in 2013?
Your answer should be very brief. 1.11. What is the ratio of the Balance of Payment (as % of service exports) in Travel services in 2011 to that in 2013?
Ensure brevity in your answer.  0.91. What is the ratio of the Balance of Payment (as % of service exports) in ICT services in 2011 to that in 2013?
Ensure brevity in your answer.  1.02. What is the ratio of the Balance of Payment (as % of service exports) of Transport services in 2012 to that in 2013?
Your response must be concise. 1.1. What is the ratio of the Balance of Payment (as % of service exports) of Travel services in 2012 to that in 2013?
Make the answer very short. 0.97. What is the ratio of the Balance of Payment (as % of service exports) in ICT services in 2012 to that in 2013?
Provide a succinct answer. 0.91. What is the difference between the highest and the second highest Balance of Payment (as % of service exports) in Transport services?
Your answer should be compact. 2.4. What is the difference between the highest and the second highest Balance of Payment (as % of service exports) in Travel services?
Your answer should be very brief. 0.49. What is the difference between the highest and the second highest Balance of Payment (as % of service exports) of ICT services?
Offer a terse response. 0.23. What is the difference between the highest and the lowest Balance of Payment (as % of service exports) in Transport services?
Your answer should be compact. 6.59. What is the difference between the highest and the lowest Balance of Payment (as % of service exports) in Travel services?
Offer a very short reply. 13.82. What is the difference between the highest and the lowest Balance of Payment (as % of service exports) in ICT services?
Your response must be concise. 5.76. 